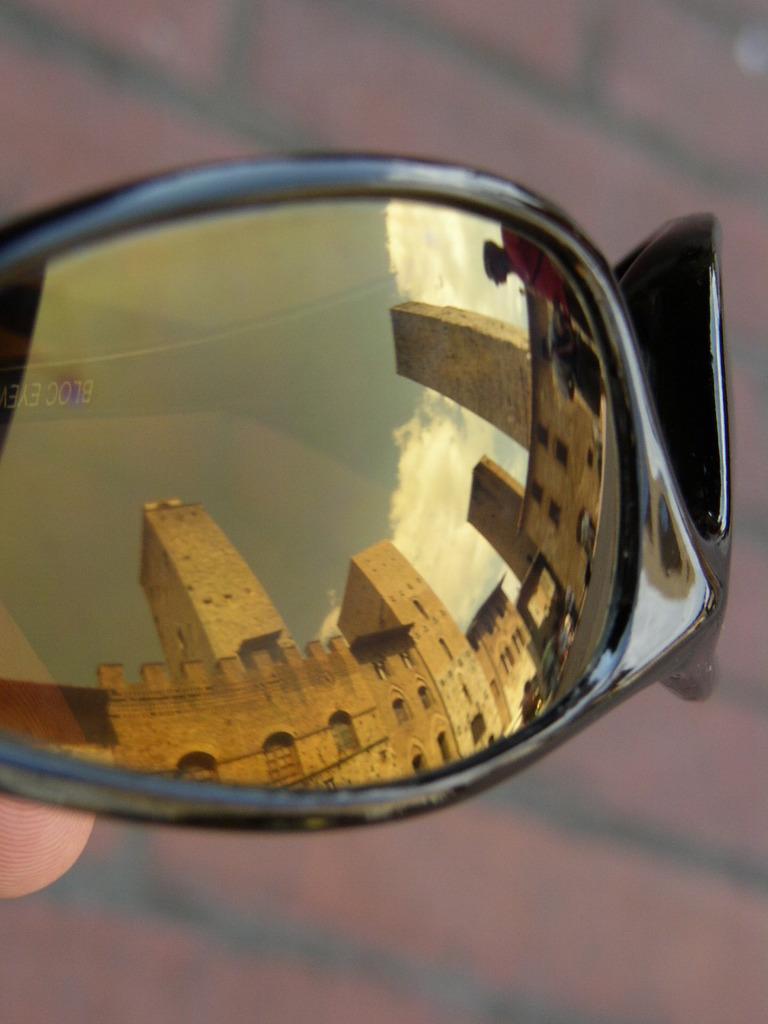Describe this image in one or two sentences. In the image there is a mirror and in the mirror there are reflections of buildings. 